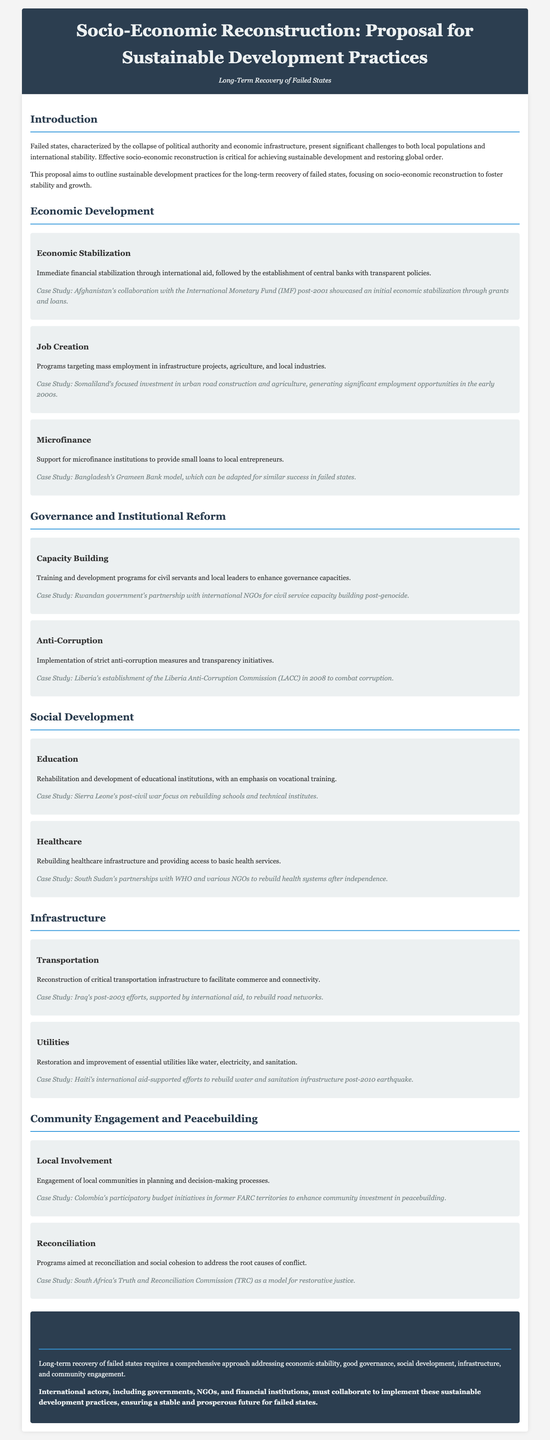What is the main focus of the proposal? The proposal primarily focuses on sustainable development practices for the long-term recovery of failed states, emphasizing socio-economic reconstruction.
Answer: Sustainable development practices What type of financial support is suggested for immediate stabilization? The proposal suggests immediate financial stabilization through international aid, which is mentioned in the Economic Stabilization subsection.
Answer: International aid Which case study is referenced for job creation? The proposal cites Somaliland's investment in urban road construction and agriculture as a successful job creation initiative from the early 2000s.
Answer: Somaliland What is a key measure proposed for governance reform? The implementation of strict anti-corruption measures and transparency initiatives is highlighted as a key governance reform measure.
Answer: Anti-corruption measures What educational focus is recommended for building back after a conflict? The proposal recommends rehabilitation and development of educational institutions with an emphasis on vocational training.
Answer: Vocational training How does the proposal suggest local communities should be involved? It emphasizes the engagement of local communities in planning and decision-making processes for enhanced recovery efforts.
Answer: Planning and decision-making Which case study represents a successful microfinance model? The proposal references Bangladesh's Grameen Bank model as a successful microfinance initiative that can be adapted for failed states.
Answer: Grameen Bank What does the conclusion emphasize as vital for the recovery of failed states? The conclusion stresses the need for a comprehensive approach addressing economic stability, governance, social development, infrastructure, and community engagement.
Answer: Comprehensive approach 